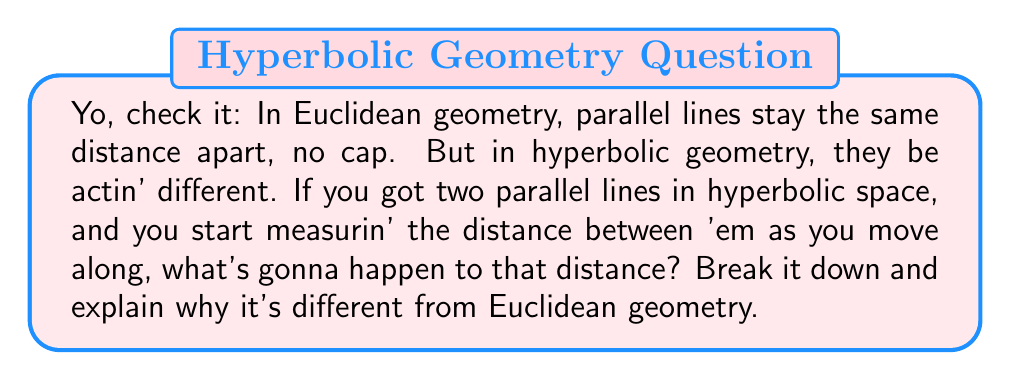Teach me how to tackle this problem. Aight, let's break this down step by step:

1) In Euclidean geometry:
   - Parallel lines stay constant distance apart
   - This distance is given by: $d_{E} = \text{constant}$

2) In hyperbolic geometry:
   - Things get wild because the space itself is curved
   - We use the hyperbolic distance formula:
     $$d_{H} = 2\sinh^{-1}\left(\frac{\sinh(r/2)}{\cosh(x)}\right)$$
   where $r$ is the initial distance between lines and $x$ is the distance along the lines

3) As $x$ increases (movin' along the lines):
   - $\cosh(x)$ increases
   - This makes the fraction $\frac{\sinh(r/2)}{\cosh(x)}$ decrease
   - So $d_{H}$ decreases

4) Visualize it:
   [asy]
   import geometry;
   
   size(200,100);
   
   path p1 = (0,0)..(100,40);
   path p2 = (0,50)..(100,60);
   
   draw(p1,blue);
   draw(p2,blue);
   
   label("x",(-10,25),W);
   draw((-5,0)--(-5,50),arrow=Arrow(TeXHead));
   
   label("Decreasing distance",right(p1),E);
   </asy]

5) Why it's different:
   - Euclidean space is flat, so parallel lines maintain constant distance
   - Hyperbolic space curves away from itself, causin' parallel lines to spread apart
   - This makes the distance between 'em decrease as you move along

So, in hyperbolic geometry, parallel lines be doin' their own thing, gettin' closer as you go further out. That's the key difference from Euclidean geometry, where they stay in their lanes, keepin' it consistent.
Answer: The distance between parallel lines in hyperbolic geometry decreases as you move along them, unlike in Euclidean geometry where it remains constant. 